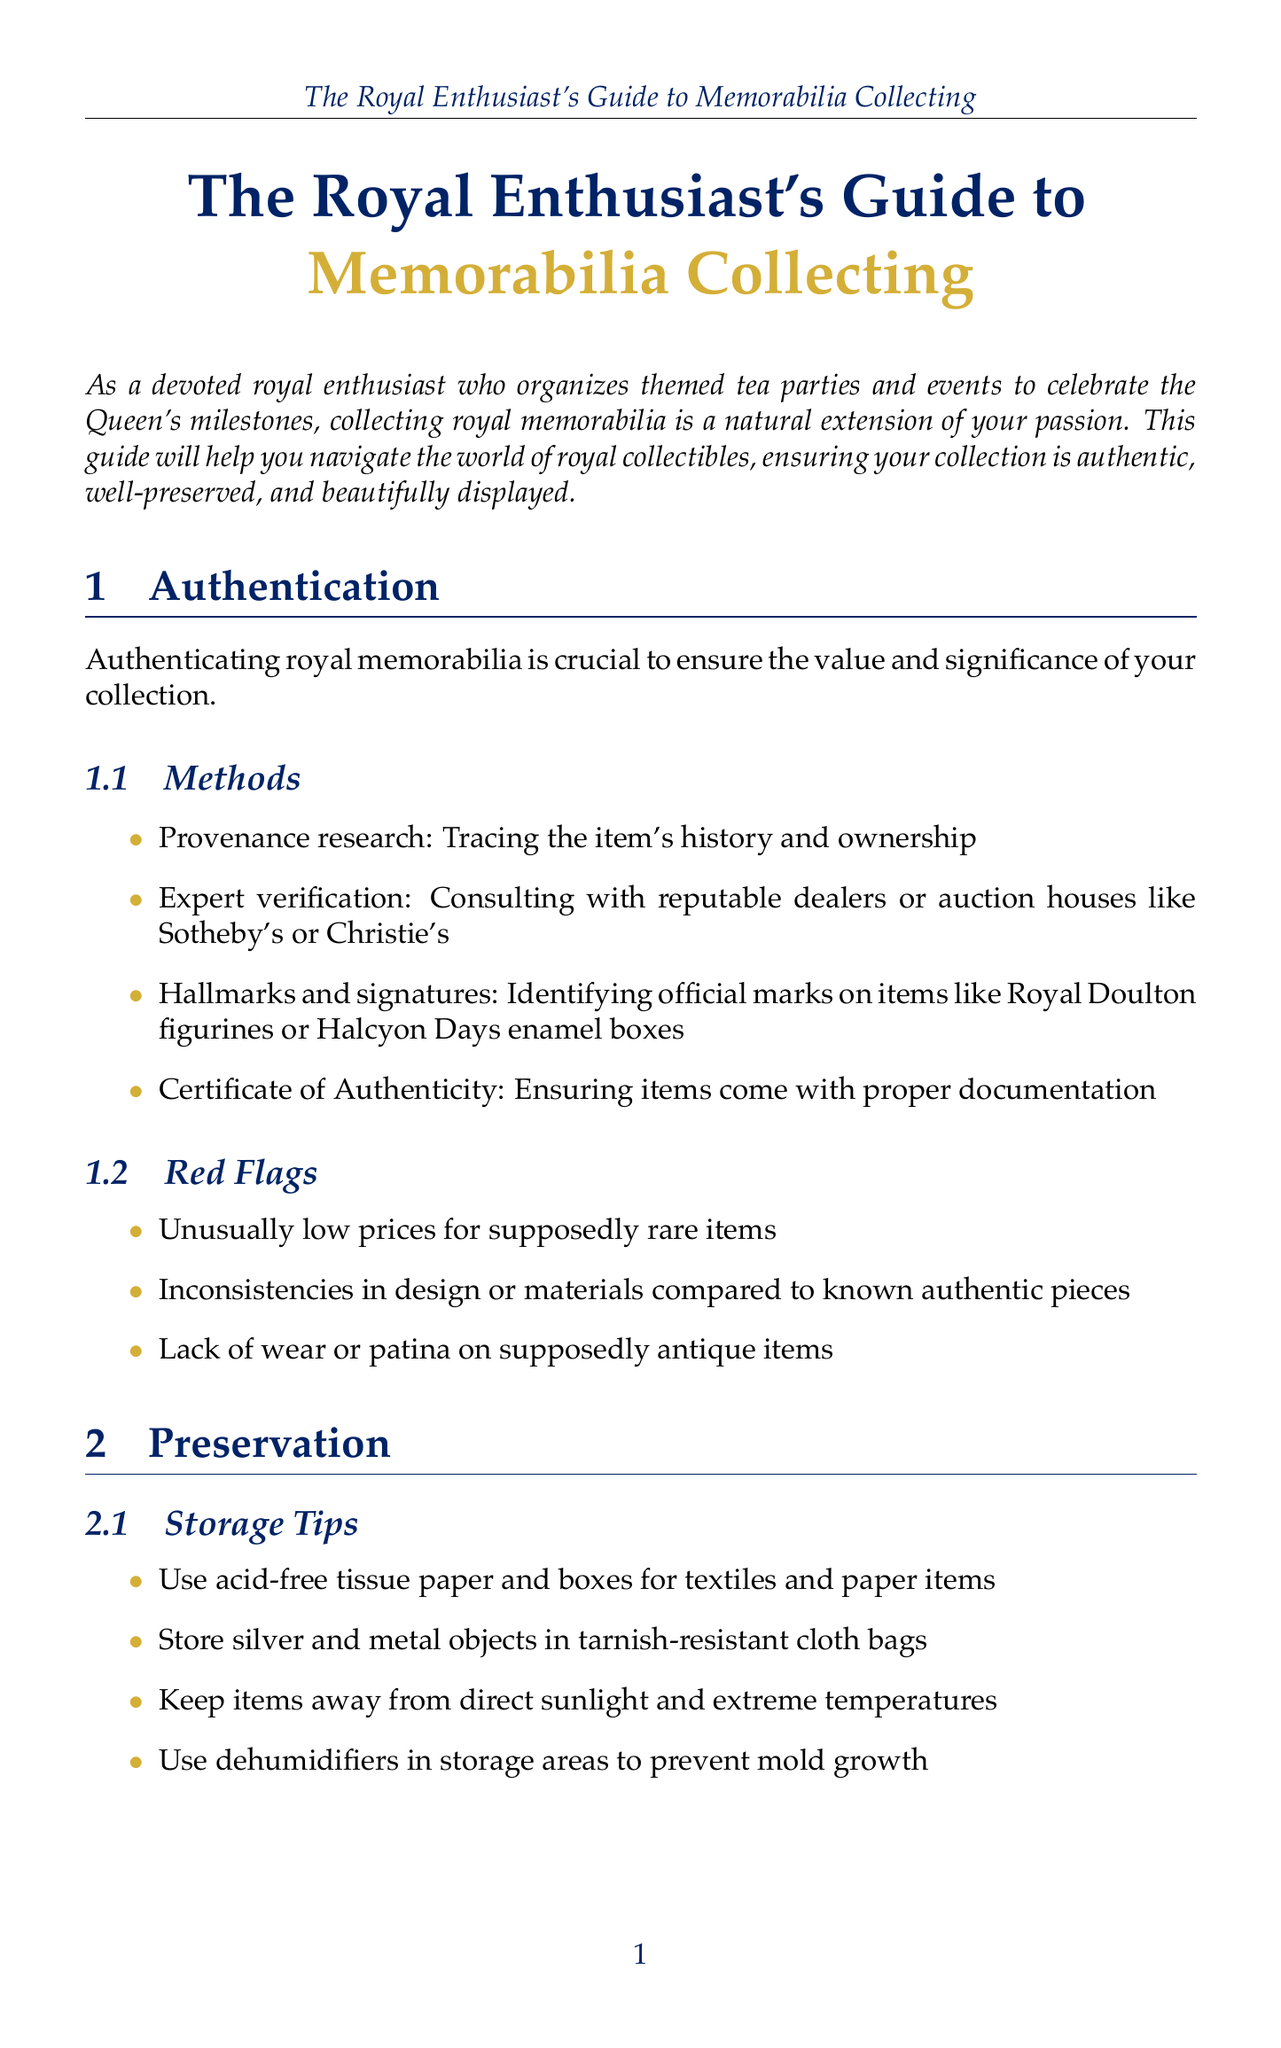what is the title of the guide? The title of the guide is provided at the beginning of the document, which sets the focus on royal memorabilia collecting.
Answer: The Royal Enthusiast's Guide to Memorabilia Collecting what is one method for authenticating royal memorabilia? One method for authentication is listed in the section about authentication and includes techniques used to verify items.
Answer: Provenance research what should you use for storing silver objects? The document specifies what materials are appropriate for different types of memorabilia to ensure their preservation.
Answer: Tarnish-resistant cloth bags name one display method suggested in the guide. The display methods outlined in the guide aim to enhance the presentation of memorabilia while ensuring their safety.
Answer: Museum-quality UV-protective glass cases what is a red flag when authenticating memorabilia? Red flags are indicators that can suggest a collectible may not be authentic, as mentioned in the authentication section.
Answer: Unusually low prices how can you incorporate memorabilia into tea parties? This question relates to the section discussing how to use memorabilia in events, adding a themed element to gatherings.
Answer: Commemorative teacups and saucers what inventory system suggestion is mentioned? The guide provides recommendations on maintaining a well-documented collection, including how to catalogue items effectively.
Answer: Digital catalog which club can you join for networking? Membership options for enthusiasts looking to connect with others in the realm of royal memorabilia are included in the document.
Answer: Royal Memorabilia Collectors Club 